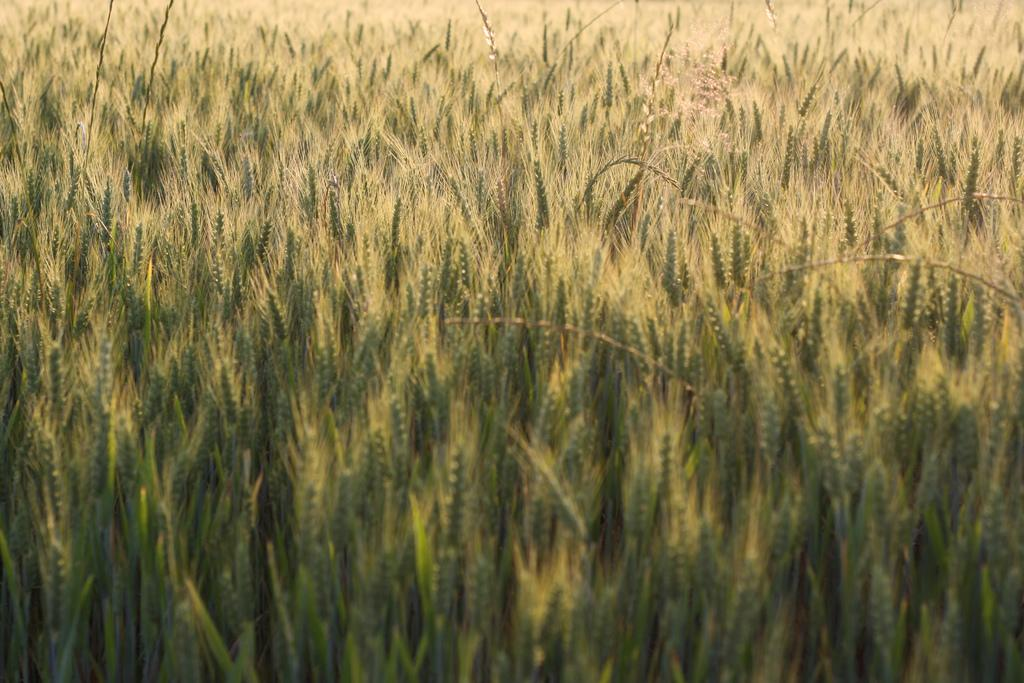What type of crop is visible in the image? There is a wheat crop in the image. Can you tell me how the beggar is reacting to the shock in the image? There is no beggar or shock present in the image; it only features a wheat crop. 